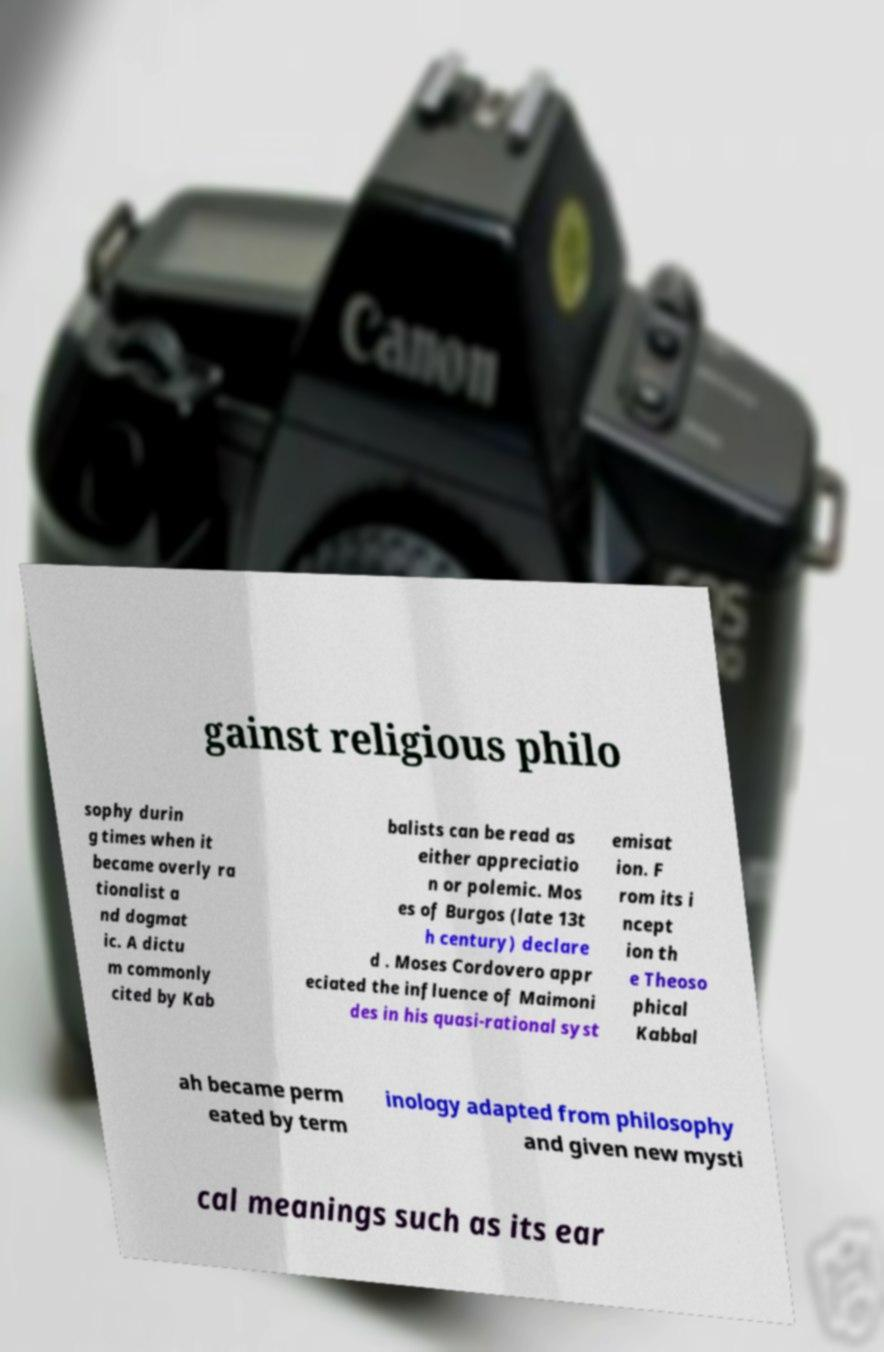There's text embedded in this image that I need extracted. Can you transcribe it verbatim? gainst religious philo sophy durin g times when it became overly ra tionalist a nd dogmat ic. A dictu m commonly cited by Kab balists can be read as either appreciatio n or polemic. Mos es of Burgos (late 13t h century) declare d . Moses Cordovero appr eciated the influence of Maimoni des in his quasi-rational syst emisat ion. F rom its i ncept ion th e Theoso phical Kabbal ah became perm eated by term inology adapted from philosophy and given new mysti cal meanings such as its ear 